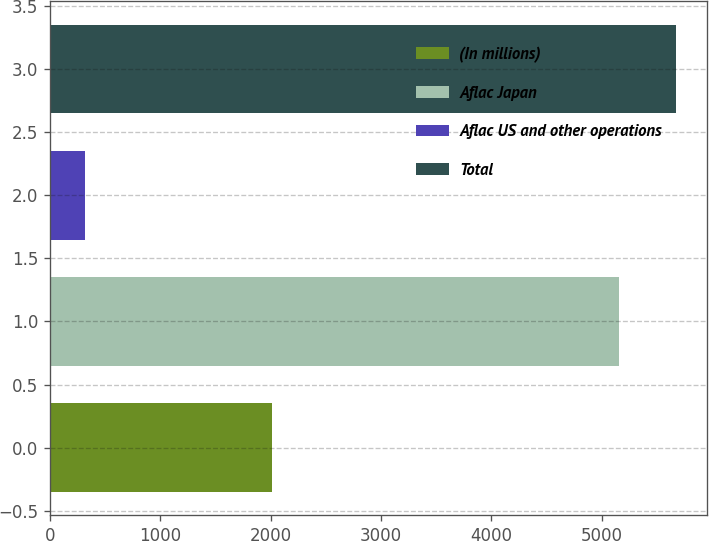Convert chart to OTSL. <chart><loc_0><loc_0><loc_500><loc_500><bar_chart><fcel>(In millions)<fcel>Aflac Japan<fcel>Aflac US and other operations<fcel>Total<nl><fcel>2009<fcel>5156<fcel>320<fcel>5671.6<nl></chart> 